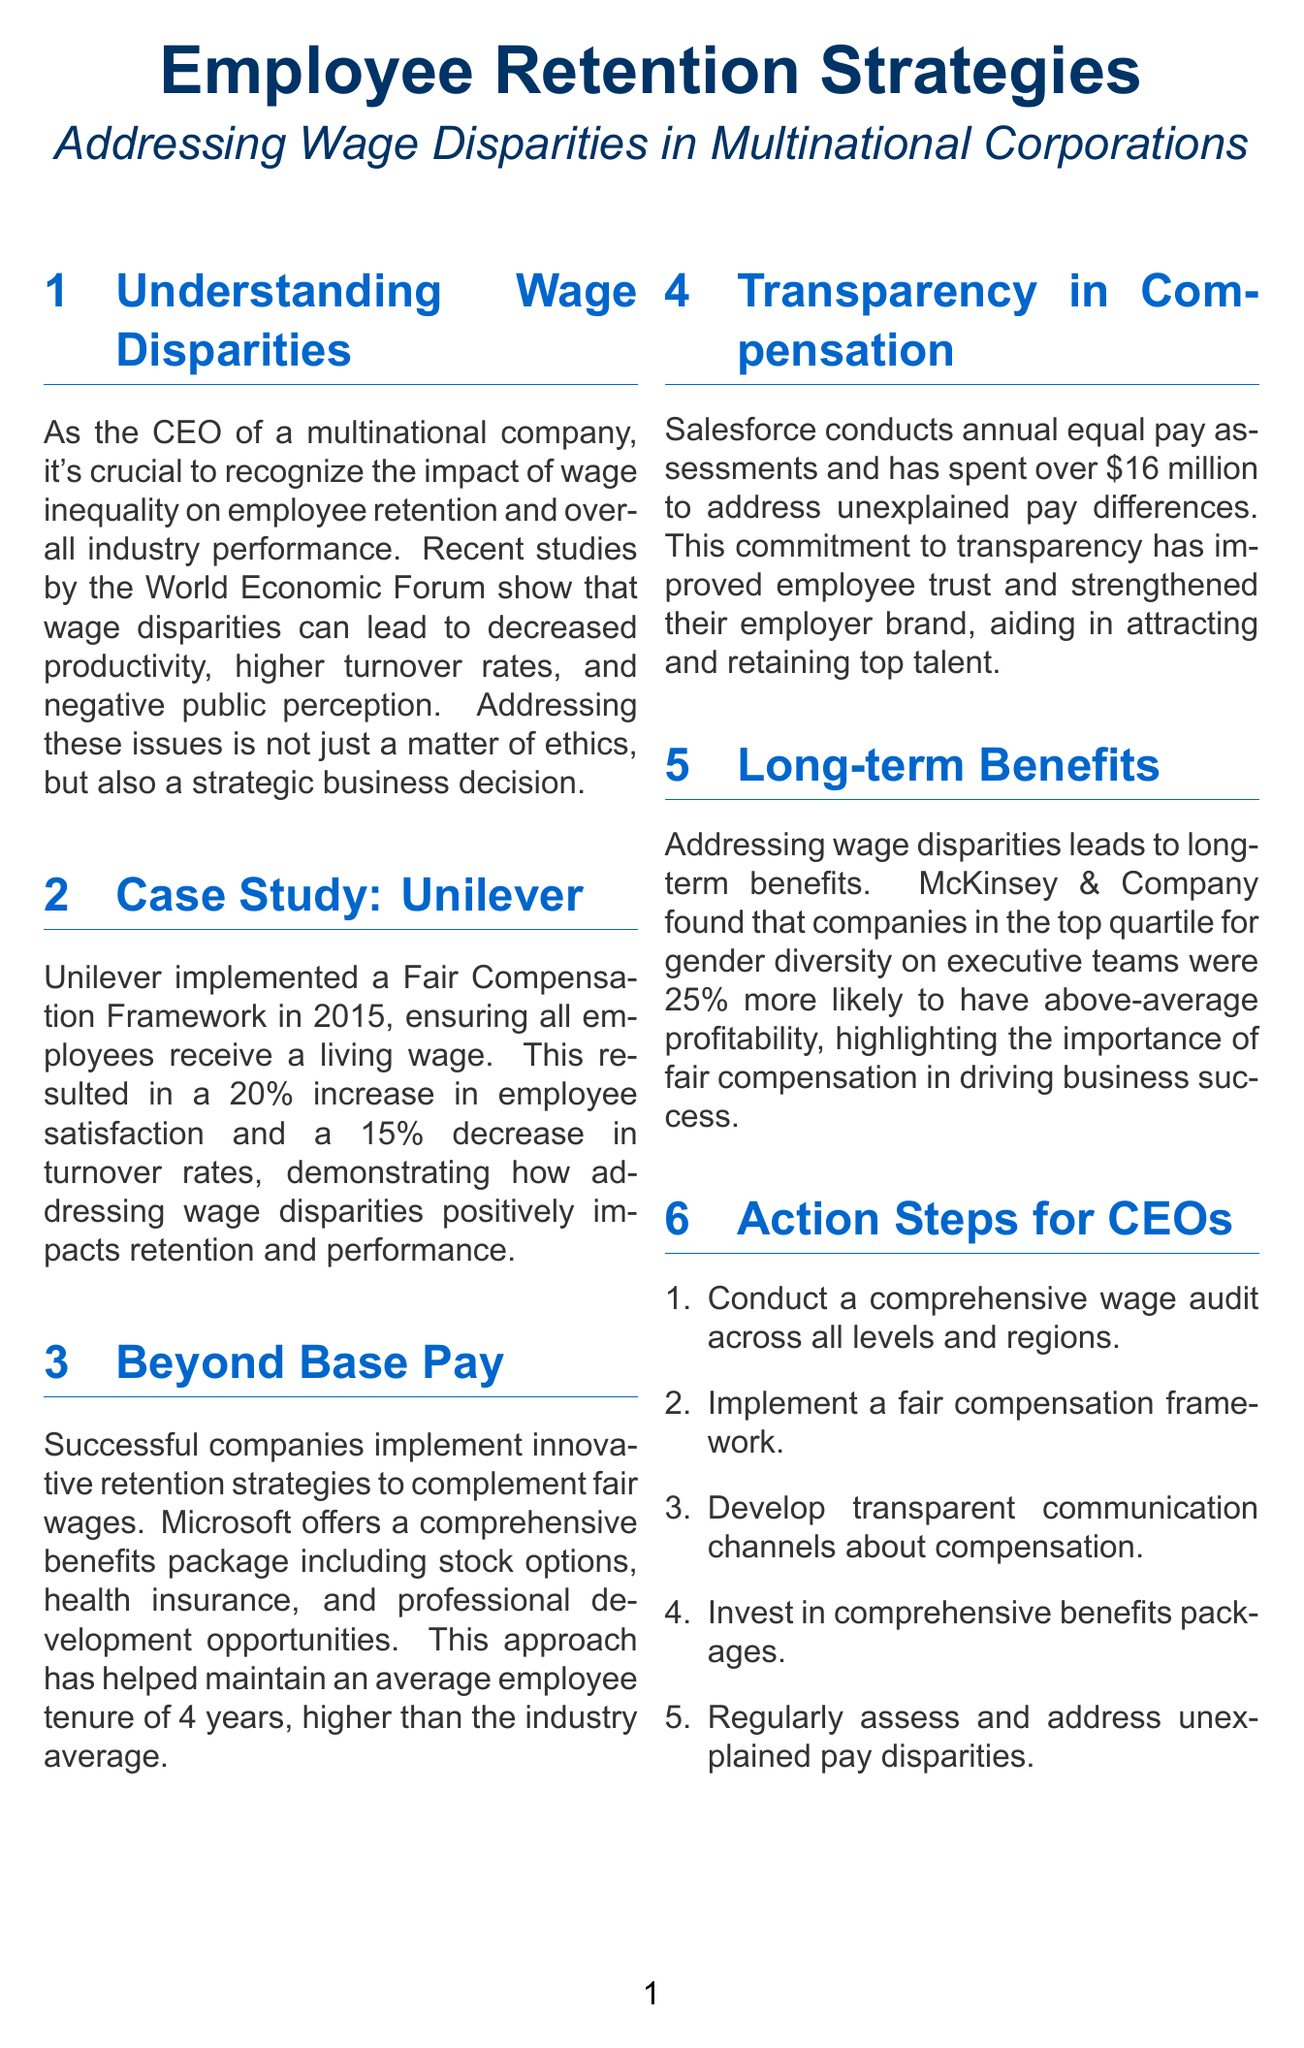what framework did Unilever implement? Unilever implemented a Fair Compensation Framework in 2015.
Answer: Fair Compensation Framework what percentage increase in employee satisfaction did Unilever experience? Unilever has seen a 20% increase in employee satisfaction.
Answer: 20% which company offers a comprehensive benefits package including stock options? Microsoft offers a comprehensive benefits package that includes stock options.
Answer: Microsoft how much did Salesforce spend to address unexplained pay differences? Salesforce has spent over $16 million to address unexplained differences in pay.
Answer: $16 million what year did Unilever implement their Fair Compensation Framework? Unilever implemented the Fair Compensation Framework in 2015.
Answer: 2015 what is the average employee tenure at Microsoft? Microsoft has maintained an average employee tenure of 4 years.
Answer: 4 years what model should CEOs consider implementing based on Unilever's example? CEOs should implement a fair compensation framework similar to Unilever's model.
Answer: fair compensation framework what organization conducted a study on gender diversity and company profitability? McKinsey & Company conducted the study.
Answer: McKinsey & Company what is one action step recommended for CEOs in the newsletter? Conduct a comprehensive wage audit across all levels and regions of your company.
Answer: wage audit 